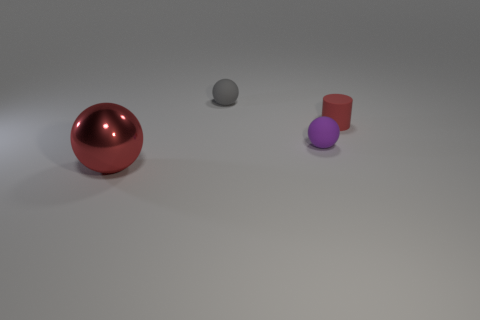Is there any other thing that is the same size as the shiny thing?
Provide a short and direct response. No. Is the size of the gray rubber thing the same as the ball that is to the left of the tiny gray matte ball?
Ensure brevity in your answer.  No. What shape is the red object that is the same material as the gray ball?
Your response must be concise. Cylinder. There is a tiny thing that is on the left side of the tiny rubber thing that is in front of the red thing that is right of the large red metal sphere; what color is it?
Keep it short and to the point. Gray. Is the number of tiny red rubber cylinders that are to the right of the large shiny object the same as the number of tiny gray things?
Your response must be concise. Yes. Is there anything else that has the same material as the tiny purple object?
Your answer should be compact. Yes. There is a large metal ball; is its color the same as the tiny sphere behind the small purple matte thing?
Ensure brevity in your answer.  No. Is there a tiny purple ball that is to the left of the red thing that is behind the small thing that is in front of the small red rubber cylinder?
Offer a terse response. Yes. Are there fewer large objects behind the gray sphere than gray blocks?
Keep it short and to the point. No. What number of other things are there of the same shape as the shiny thing?
Offer a very short reply. 2. 